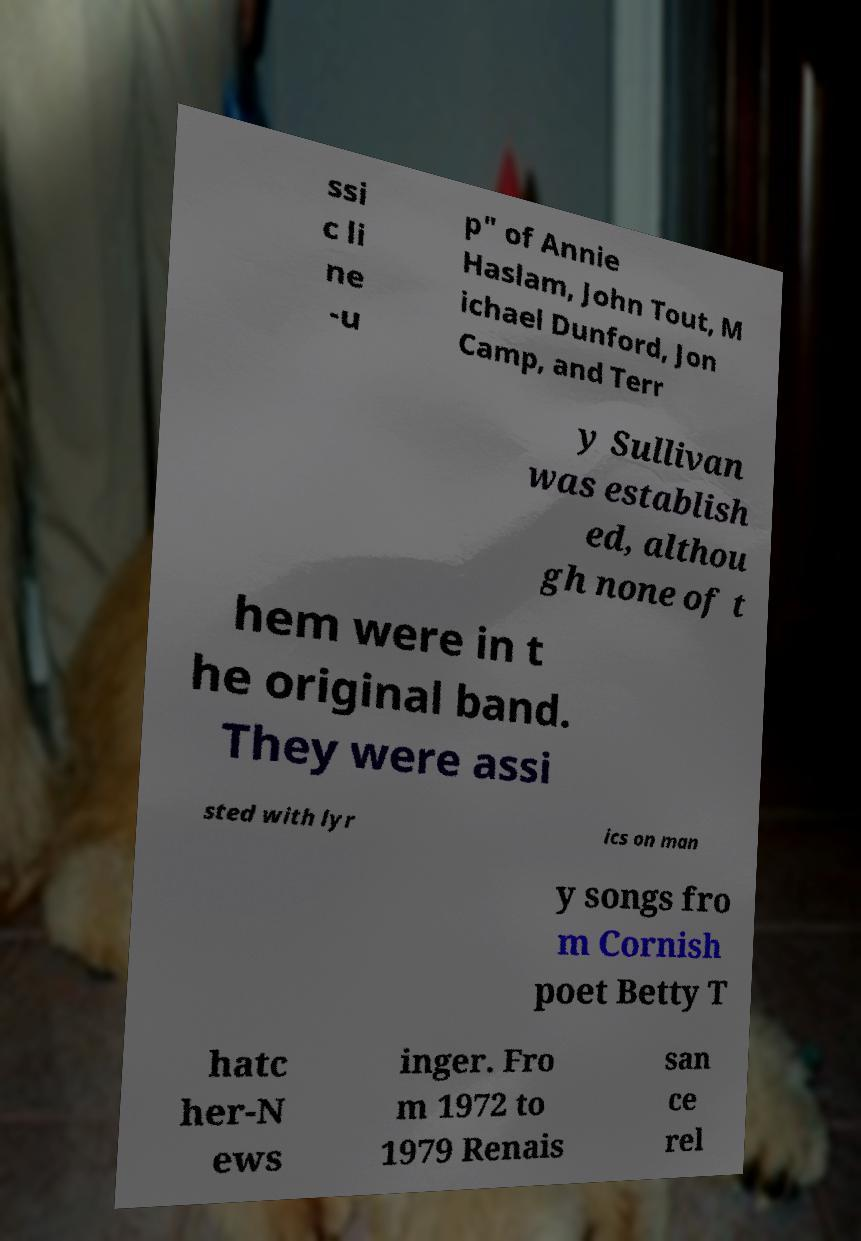Can you accurately transcribe the text from the provided image for me? ssi c li ne -u p" of Annie Haslam, John Tout, M ichael Dunford, Jon Camp, and Terr y Sullivan was establish ed, althou gh none of t hem were in t he original band. They were assi sted with lyr ics on man y songs fro m Cornish poet Betty T hatc her-N ews inger. Fro m 1972 to 1979 Renais san ce rel 